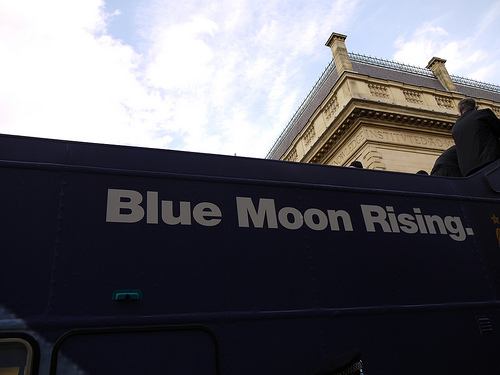<image>
Can you confirm if the board is behind the building? Yes. From this viewpoint, the board is positioned behind the building, with the building partially or fully occluding the board. 